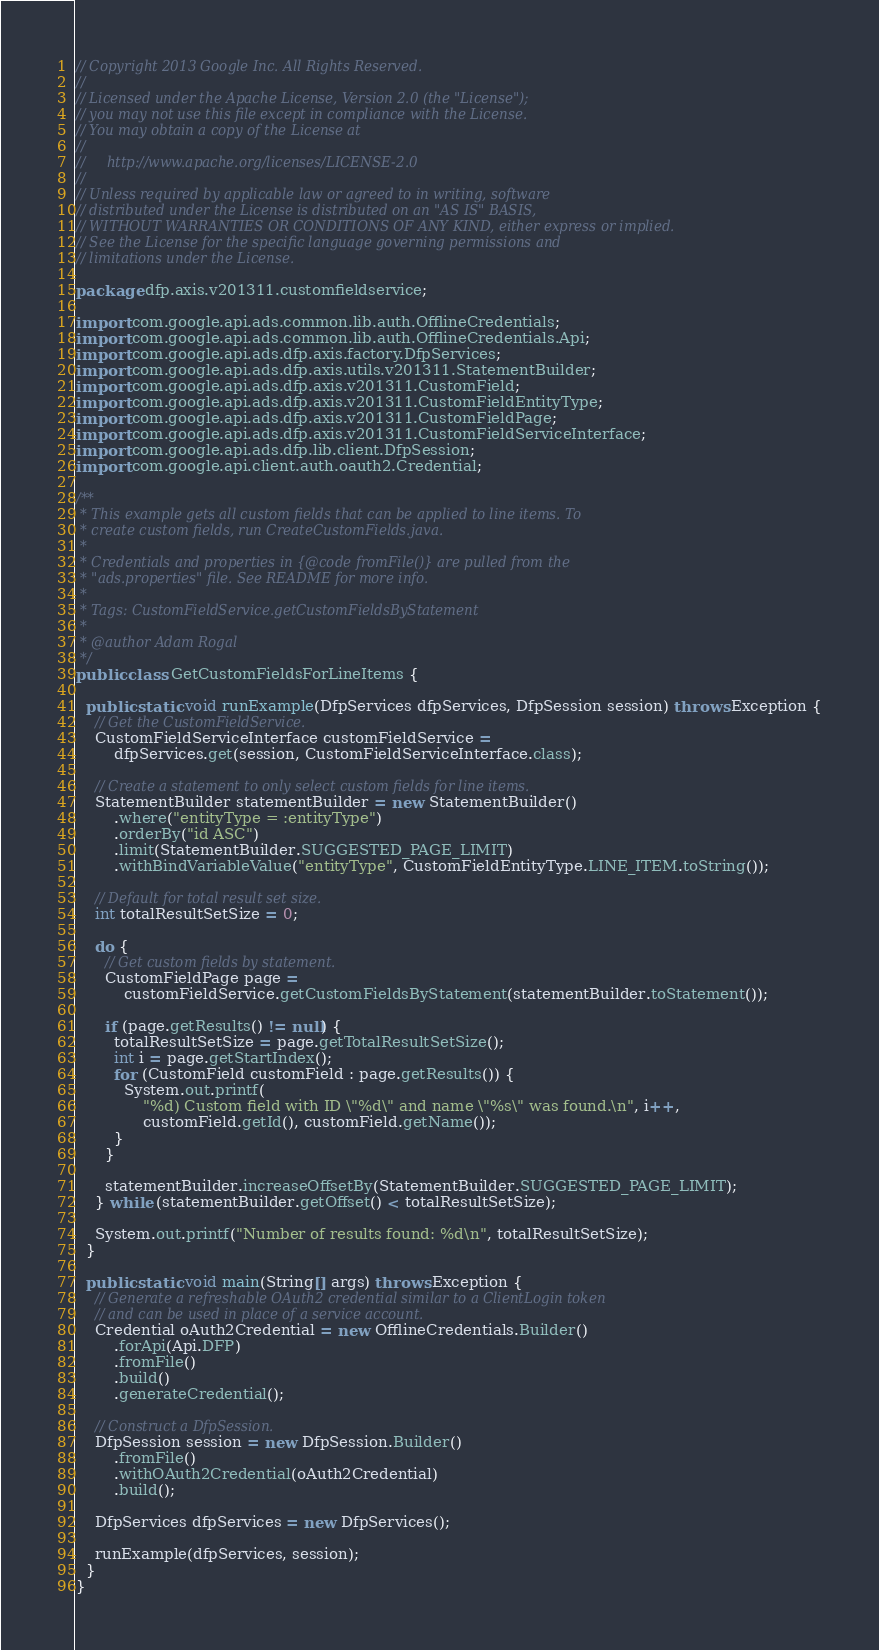Convert code to text. <code><loc_0><loc_0><loc_500><loc_500><_Java_>// Copyright 2013 Google Inc. All Rights Reserved.
//
// Licensed under the Apache License, Version 2.0 (the "License");
// you may not use this file except in compliance with the License.
// You may obtain a copy of the License at
//
//     http://www.apache.org/licenses/LICENSE-2.0
//
// Unless required by applicable law or agreed to in writing, software
// distributed under the License is distributed on an "AS IS" BASIS,
// WITHOUT WARRANTIES OR CONDITIONS OF ANY KIND, either express or implied.
// See the License for the specific language governing permissions and
// limitations under the License.

package dfp.axis.v201311.customfieldservice;

import com.google.api.ads.common.lib.auth.OfflineCredentials;
import com.google.api.ads.common.lib.auth.OfflineCredentials.Api;
import com.google.api.ads.dfp.axis.factory.DfpServices;
import com.google.api.ads.dfp.axis.utils.v201311.StatementBuilder;
import com.google.api.ads.dfp.axis.v201311.CustomField;
import com.google.api.ads.dfp.axis.v201311.CustomFieldEntityType;
import com.google.api.ads.dfp.axis.v201311.CustomFieldPage;
import com.google.api.ads.dfp.axis.v201311.CustomFieldServiceInterface;
import com.google.api.ads.dfp.lib.client.DfpSession;
import com.google.api.client.auth.oauth2.Credential;

/**
 * This example gets all custom fields that can be applied to line items. To
 * create custom fields, run CreateCustomFields.java.
 *
 * Credentials and properties in {@code fromFile()} are pulled from the
 * "ads.properties" file. See README for more info.
 *
 * Tags: CustomFieldService.getCustomFieldsByStatement
 *
 * @author Adam Rogal
 */
public class GetCustomFieldsForLineItems {

  public static void runExample(DfpServices dfpServices, DfpSession session) throws Exception {
    // Get the CustomFieldService.
    CustomFieldServiceInterface customFieldService =
        dfpServices.get(session, CustomFieldServiceInterface.class);

    // Create a statement to only select custom fields for line items.
    StatementBuilder statementBuilder = new StatementBuilder()
        .where("entityType = :entityType")
        .orderBy("id ASC")
        .limit(StatementBuilder.SUGGESTED_PAGE_LIMIT)
        .withBindVariableValue("entityType", CustomFieldEntityType.LINE_ITEM.toString());

    // Default for total result set size.
    int totalResultSetSize = 0;

    do {
      // Get custom fields by statement.
      CustomFieldPage page =
          customFieldService.getCustomFieldsByStatement(statementBuilder.toStatement());

      if (page.getResults() != null) {
        totalResultSetSize = page.getTotalResultSetSize();
        int i = page.getStartIndex();
        for (CustomField customField : page.getResults()) {
          System.out.printf(
              "%d) Custom field with ID \"%d\" and name \"%s\" was found.\n", i++,
              customField.getId(), customField.getName());
        }
      }

      statementBuilder.increaseOffsetBy(StatementBuilder.SUGGESTED_PAGE_LIMIT);
    } while (statementBuilder.getOffset() < totalResultSetSize);

    System.out.printf("Number of results found: %d\n", totalResultSetSize);
  }

  public static void main(String[] args) throws Exception {
    // Generate a refreshable OAuth2 credential similar to a ClientLogin token
    // and can be used in place of a service account.
    Credential oAuth2Credential = new OfflineCredentials.Builder()
        .forApi(Api.DFP)
        .fromFile()
        .build()
        .generateCredential();

    // Construct a DfpSession.
    DfpSession session = new DfpSession.Builder()
        .fromFile()
        .withOAuth2Credential(oAuth2Credential)
        .build();

    DfpServices dfpServices = new DfpServices();

    runExample(dfpServices, session);
  }
}
</code> 